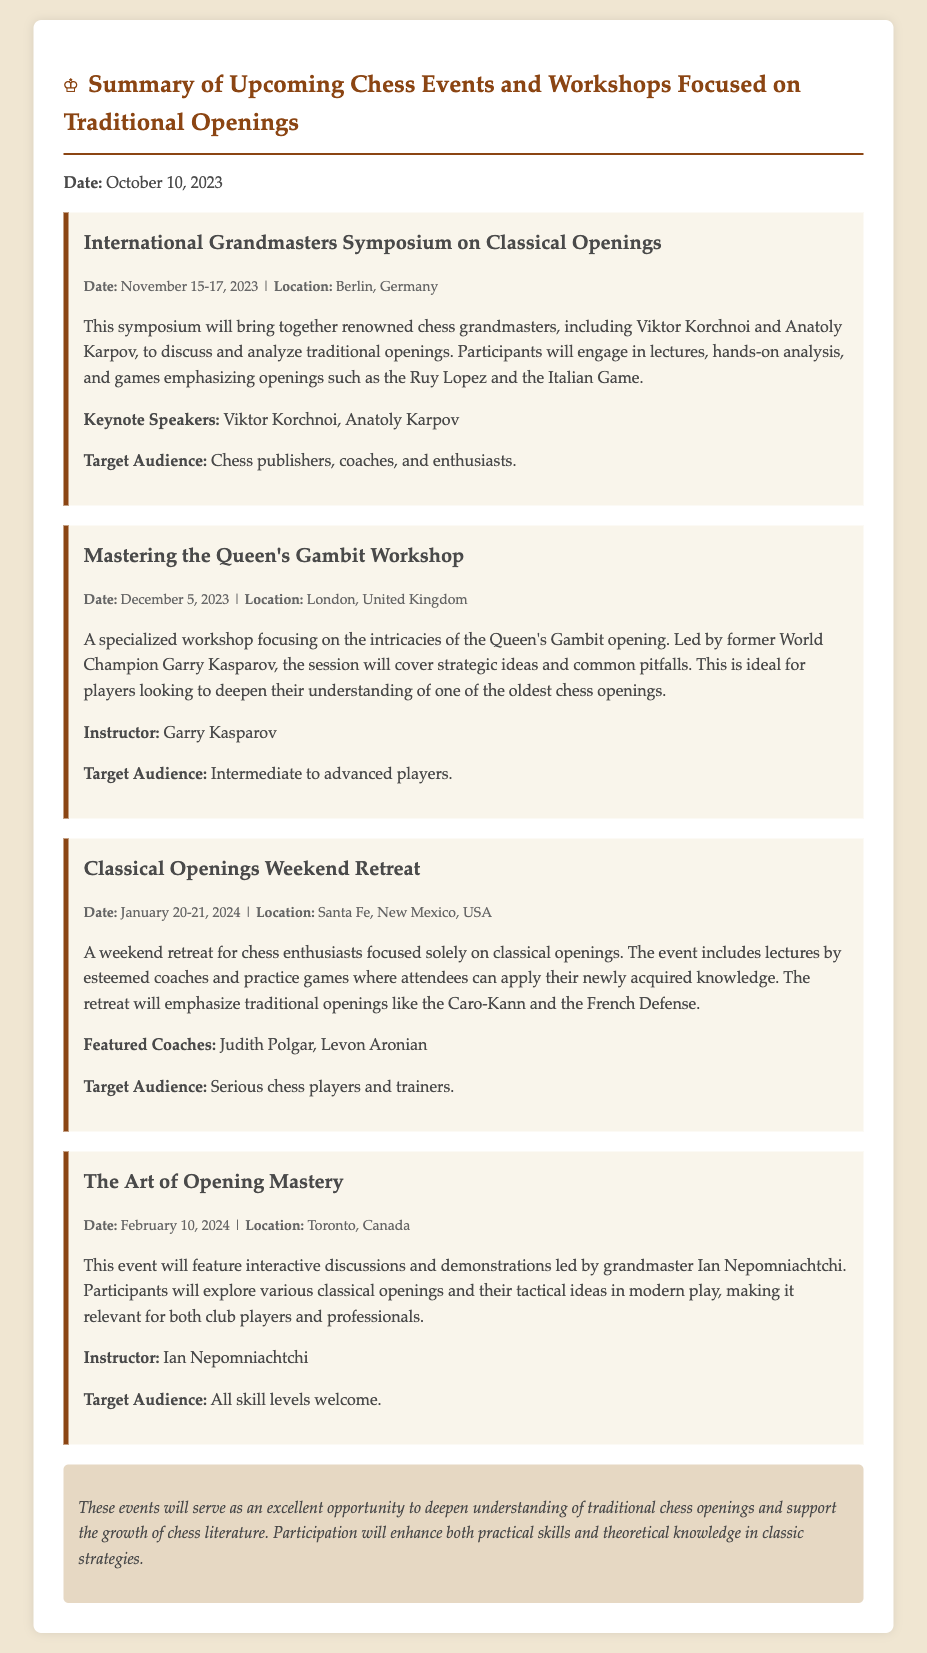What is the date of the International Grandmasters Symposium? The date is specified in the document under the event details for the International Grandmasters Symposium.
Answer: November 15-17, 2023 Who is leading the workshop on the Queen's Gambit? The document states that the workshop is led by Garry Kasparov.
Answer: Garry Kasparov What is the target audience for the Classical Openings Weekend Retreat? The document mentions the target audience for this retreat specifically.
Answer: Serious chess players and trainers Which opening will be emphasized in the Mastering the Queen's Gambit Workshop? The document clearly mentions that the Queen's Gambit will be the focus of this workshop.
Answer: Queen's Gambit How many key speakers are listed for the International Grandmasters Symposium? The document lists Viktor Korchnoi and Anatoly Karpov as the keynote speakers, totaling two.
Answer: Two What location will host The Art of Opening Mastery event? The document provides the location of The Art of Opening Mastery event.
Answer: Toronto, Canada Which openings will be emphasized in the Classical Openings Weekend Retreat? The document specifies the traditional openings that will be addressed during the retreat.
Answer: Caro-Kann and French Defense What is the date of the upcoming workshop focused on the Queen's Gambit? The specific date of the workshop is indicated in the event details for the Queen's Gambit workshop.
Answer: December 5, 2023 What is the overarching theme of the upcoming events documented? The memo summarizes the focus of all events which is specified in the conclusion.
Answer: Traditional chess openings 